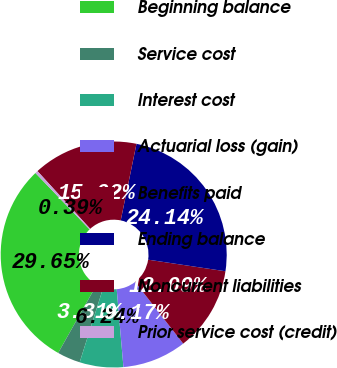Convert chart. <chart><loc_0><loc_0><loc_500><loc_500><pie_chart><fcel>Beginning balance<fcel>Service cost<fcel>Interest cost<fcel>Actuarial loss (gain)<fcel>Benefits paid<fcel>Ending balance<fcel>Noncurrent liabilities<fcel>Prior service cost (credit)<nl><fcel>29.65%<fcel>3.31%<fcel>6.24%<fcel>9.17%<fcel>12.09%<fcel>24.14%<fcel>15.02%<fcel>0.39%<nl></chart> 